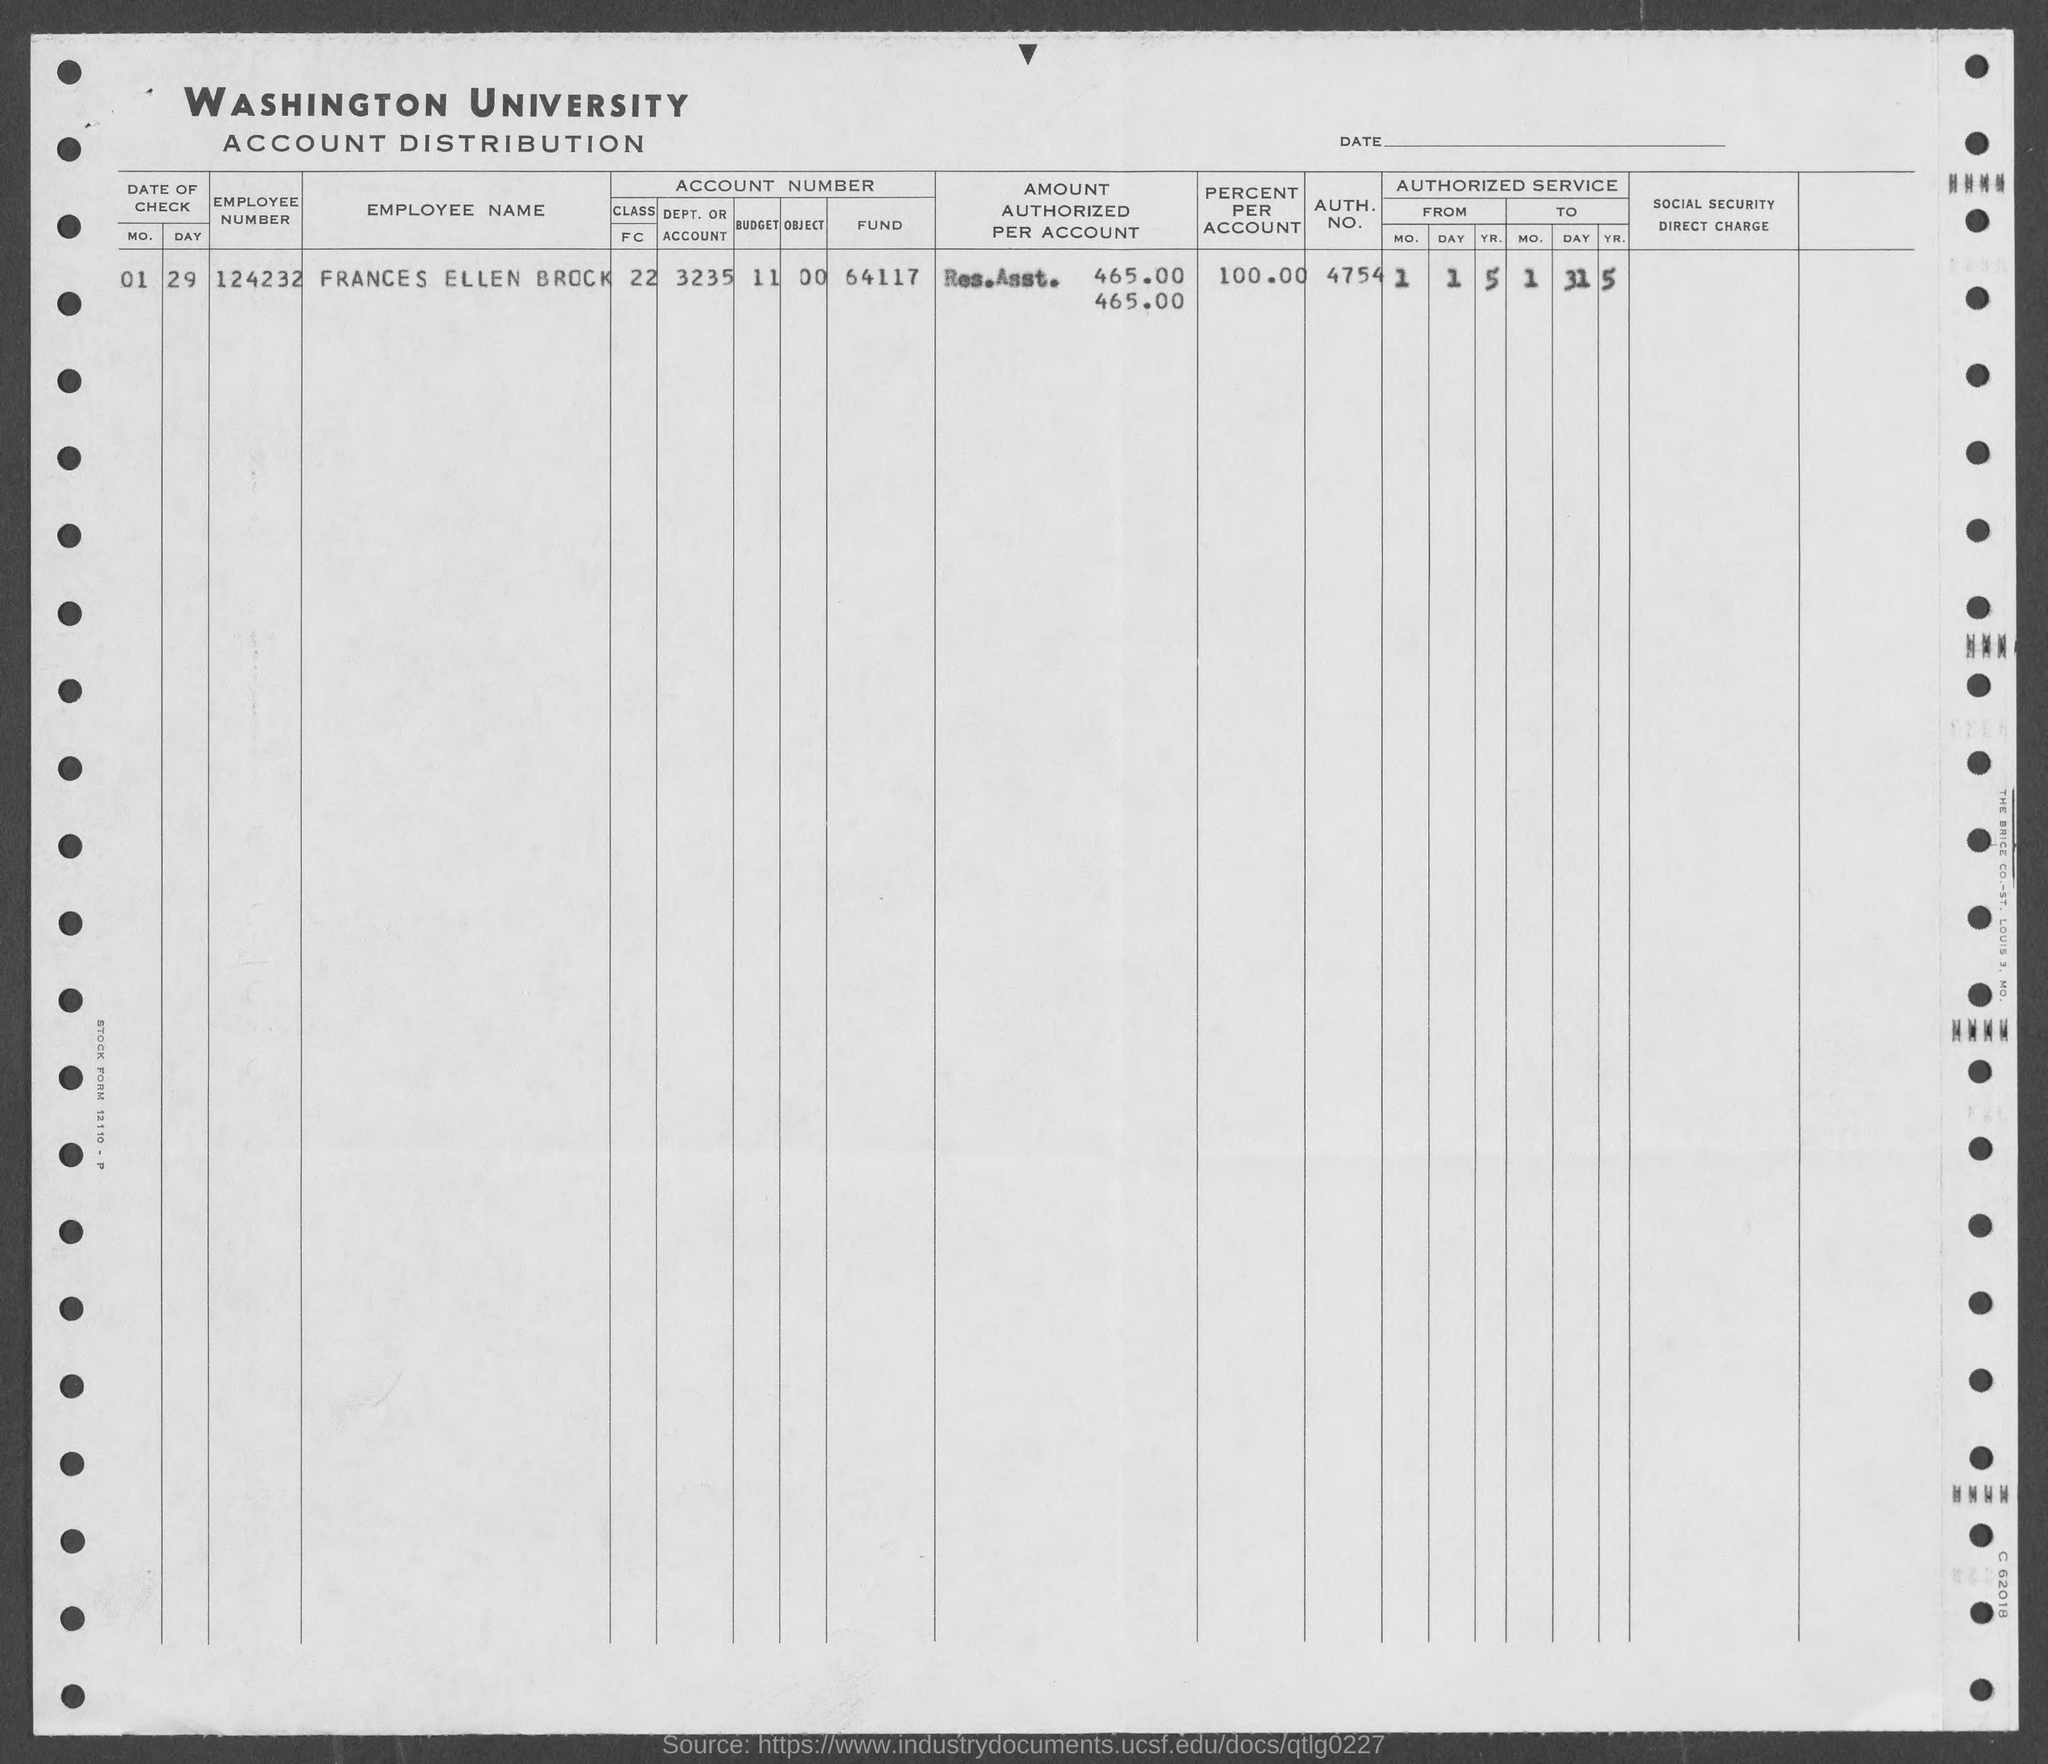What is the employee number of frances ellen brock?
Give a very brief answer. 124232. What is the auth. no. of frances ellen brock?
Your answer should be compact. 4754. What is the percent per account of frances ellen brock ?
Offer a terse response. 100%. 